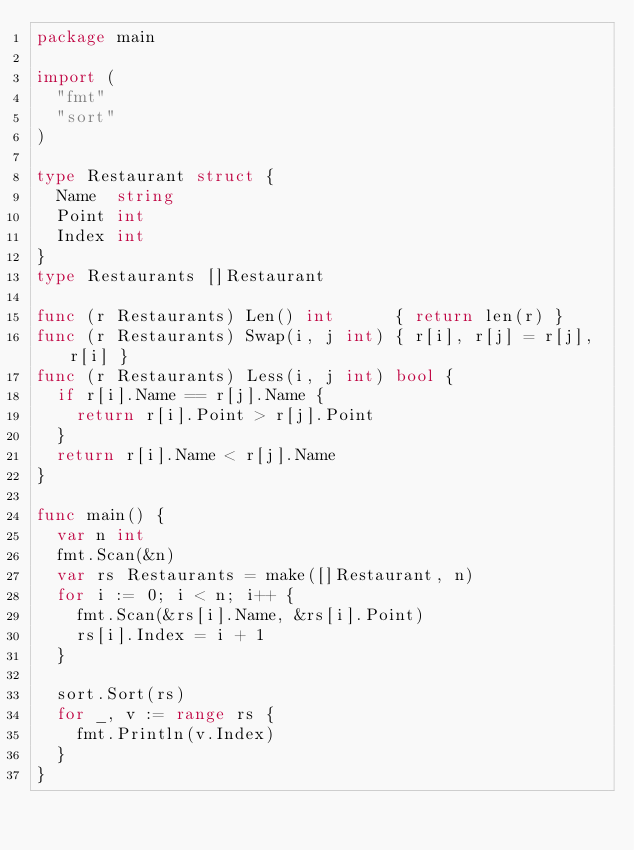<code> <loc_0><loc_0><loc_500><loc_500><_Go_>package main

import (
	"fmt"
	"sort"
)

type Restaurant struct {
	Name  string
	Point int
	Index int
}
type Restaurants []Restaurant

func (r Restaurants) Len() int      { return len(r) }
func (r Restaurants) Swap(i, j int) { r[i], r[j] = r[j], r[i] }
func (r Restaurants) Less(i, j int) bool {
	if r[i].Name == r[j].Name {
		return r[i].Point > r[j].Point
	}
	return r[i].Name < r[j].Name
}

func main() {
	var n int
	fmt.Scan(&n)
	var rs Restaurants = make([]Restaurant, n)
	for i := 0; i < n; i++ {
		fmt.Scan(&rs[i].Name, &rs[i].Point)
		rs[i].Index = i + 1
	}

	sort.Sort(rs)
	for _, v := range rs {
		fmt.Println(v.Index)
	}
}
</code> 